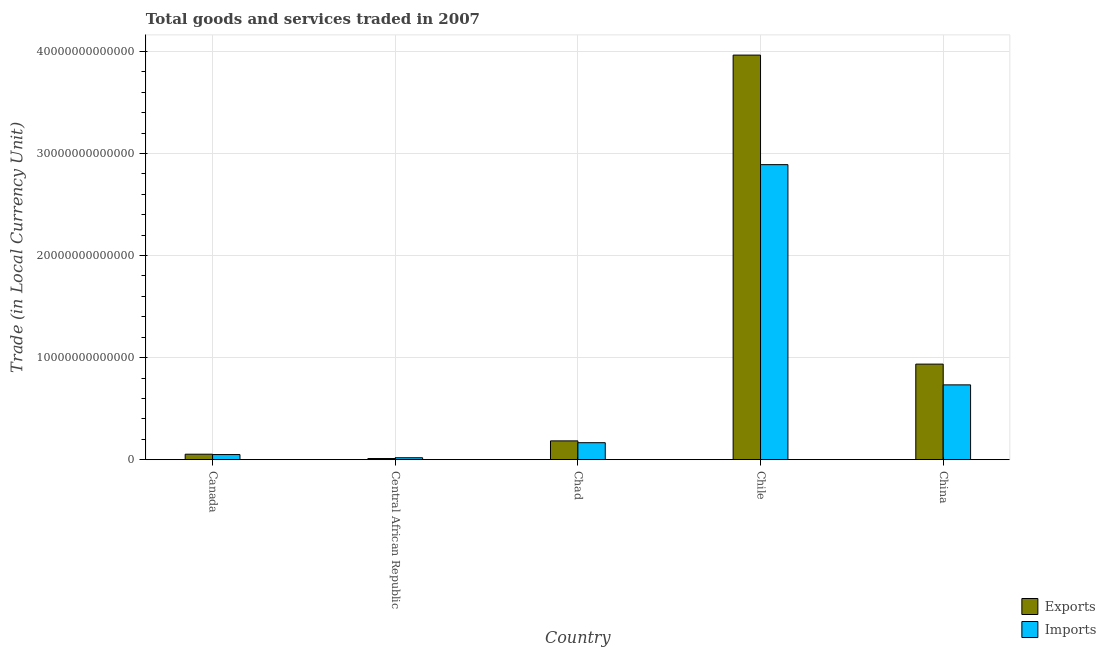How many groups of bars are there?
Your answer should be compact. 5. Are the number of bars per tick equal to the number of legend labels?
Give a very brief answer. Yes. What is the label of the 5th group of bars from the left?
Provide a succinct answer. China. What is the export of goods and services in China?
Make the answer very short. 9.36e+12. Across all countries, what is the maximum export of goods and services?
Make the answer very short. 3.96e+13. Across all countries, what is the minimum export of goods and services?
Make the answer very short. 1.15e+11. In which country was the imports of goods and services minimum?
Your answer should be compact. Central African Republic. What is the total imports of goods and services in the graph?
Your answer should be compact. 3.86e+13. What is the difference between the imports of goods and services in Chile and that in China?
Your answer should be compact. 2.16e+13. What is the difference between the export of goods and services in Chad and the imports of goods and services in Chile?
Give a very brief answer. -2.71e+13. What is the average imports of goods and services per country?
Ensure brevity in your answer.  7.72e+12. What is the difference between the imports of goods and services and export of goods and services in Canada?
Provide a succinct answer. -3.33e+1. What is the ratio of the imports of goods and services in Canada to that in Central African Republic?
Provide a succinct answer. 2.64. Is the difference between the export of goods and services in Canada and Chad greater than the difference between the imports of goods and services in Canada and Chad?
Provide a short and direct response. No. What is the difference between the highest and the second highest imports of goods and services?
Give a very brief answer. 2.16e+13. What is the difference between the highest and the lowest imports of goods and services?
Your response must be concise. 2.87e+13. In how many countries, is the export of goods and services greater than the average export of goods and services taken over all countries?
Provide a short and direct response. 1. Is the sum of the export of goods and services in Canada and Chad greater than the maximum imports of goods and services across all countries?
Provide a short and direct response. No. What does the 2nd bar from the left in Chile represents?
Make the answer very short. Imports. What does the 1st bar from the right in Chile represents?
Give a very brief answer. Imports. What is the difference between two consecutive major ticks on the Y-axis?
Provide a succinct answer. 1.00e+13. Are the values on the major ticks of Y-axis written in scientific E-notation?
Provide a short and direct response. No. Does the graph contain any zero values?
Make the answer very short. No. Does the graph contain grids?
Provide a succinct answer. Yes. How many legend labels are there?
Offer a terse response. 2. What is the title of the graph?
Ensure brevity in your answer.  Total goods and services traded in 2007. Does "Non-residents" appear as one of the legend labels in the graph?
Provide a succinct answer. No. What is the label or title of the X-axis?
Your answer should be compact. Country. What is the label or title of the Y-axis?
Offer a terse response. Trade (in Local Currency Unit). What is the Trade (in Local Currency Unit) in Exports in Canada?
Your response must be concise. 5.37e+11. What is the Trade (in Local Currency Unit) of Imports in Canada?
Your response must be concise. 5.04e+11. What is the Trade (in Local Currency Unit) of Exports in Central African Republic?
Offer a terse response. 1.15e+11. What is the Trade (in Local Currency Unit) of Imports in Central African Republic?
Ensure brevity in your answer.  1.91e+11. What is the Trade (in Local Currency Unit) in Exports in Chad?
Ensure brevity in your answer.  1.84e+12. What is the Trade (in Local Currency Unit) in Imports in Chad?
Your answer should be very brief. 1.67e+12. What is the Trade (in Local Currency Unit) of Exports in Chile?
Your response must be concise. 3.96e+13. What is the Trade (in Local Currency Unit) in Imports in Chile?
Provide a succinct answer. 2.89e+13. What is the Trade (in Local Currency Unit) of Exports in China?
Give a very brief answer. 9.36e+12. What is the Trade (in Local Currency Unit) in Imports in China?
Give a very brief answer. 7.33e+12. Across all countries, what is the maximum Trade (in Local Currency Unit) in Exports?
Give a very brief answer. 3.96e+13. Across all countries, what is the maximum Trade (in Local Currency Unit) of Imports?
Ensure brevity in your answer.  2.89e+13. Across all countries, what is the minimum Trade (in Local Currency Unit) of Exports?
Your answer should be very brief. 1.15e+11. Across all countries, what is the minimum Trade (in Local Currency Unit) of Imports?
Your answer should be very brief. 1.91e+11. What is the total Trade (in Local Currency Unit) in Exports in the graph?
Provide a short and direct response. 5.15e+13. What is the total Trade (in Local Currency Unit) of Imports in the graph?
Ensure brevity in your answer.  3.86e+13. What is the difference between the Trade (in Local Currency Unit) of Exports in Canada and that in Central African Republic?
Keep it short and to the point. 4.23e+11. What is the difference between the Trade (in Local Currency Unit) in Imports in Canada and that in Central African Republic?
Your answer should be compact. 3.13e+11. What is the difference between the Trade (in Local Currency Unit) of Exports in Canada and that in Chad?
Make the answer very short. -1.31e+12. What is the difference between the Trade (in Local Currency Unit) of Imports in Canada and that in Chad?
Offer a terse response. -1.16e+12. What is the difference between the Trade (in Local Currency Unit) of Exports in Canada and that in Chile?
Give a very brief answer. -3.91e+13. What is the difference between the Trade (in Local Currency Unit) in Imports in Canada and that in Chile?
Offer a terse response. -2.84e+13. What is the difference between the Trade (in Local Currency Unit) of Exports in Canada and that in China?
Ensure brevity in your answer.  -8.83e+12. What is the difference between the Trade (in Local Currency Unit) in Imports in Canada and that in China?
Your answer should be very brief. -6.83e+12. What is the difference between the Trade (in Local Currency Unit) in Exports in Central African Republic and that in Chad?
Give a very brief answer. -1.73e+12. What is the difference between the Trade (in Local Currency Unit) of Imports in Central African Republic and that in Chad?
Make the answer very short. -1.47e+12. What is the difference between the Trade (in Local Currency Unit) in Exports in Central African Republic and that in Chile?
Your answer should be very brief. -3.95e+13. What is the difference between the Trade (in Local Currency Unit) of Imports in Central African Republic and that in Chile?
Offer a terse response. -2.87e+13. What is the difference between the Trade (in Local Currency Unit) in Exports in Central African Republic and that in China?
Your answer should be very brief. -9.25e+12. What is the difference between the Trade (in Local Currency Unit) of Imports in Central African Republic and that in China?
Provide a short and direct response. -7.14e+12. What is the difference between the Trade (in Local Currency Unit) in Exports in Chad and that in Chile?
Ensure brevity in your answer.  -3.78e+13. What is the difference between the Trade (in Local Currency Unit) of Imports in Chad and that in Chile?
Provide a succinct answer. -2.72e+13. What is the difference between the Trade (in Local Currency Unit) of Exports in Chad and that in China?
Ensure brevity in your answer.  -7.52e+12. What is the difference between the Trade (in Local Currency Unit) of Imports in Chad and that in China?
Keep it short and to the point. -5.66e+12. What is the difference between the Trade (in Local Currency Unit) of Exports in Chile and that in China?
Give a very brief answer. 3.03e+13. What is the difference between the Trade (in Local Currency Unit) in Imports in Chile and that in China?
Ensure brevity in your answer.  2.16e+13. What is the difference between the Trade (in Local Currency Unit) in Exports in Canada and the Trade (in Local Currency Unit) in Imports in Central African Republic?
Your response must be concise. 3.47e+11. What is the difference between the Trade (in Local Currency Unit) in Exports in Canada and the Trade (in Local Currency Unit) in Imports in Chad?
Make the answer very short. -1.13e+12. What is the difference between the Trade (in Local Currency Unit) of Exports in Canada and the Trade (in Local Currency Unit) of Imports in Chile?
Provide a succinct answer. -2.84e+13. What is the difference between the Trade (in Local Currency Unit) in Exports in Canada and the Trade (in Local Currency Unit) in Imports in China?
Your response must be concise. -6.79e+12. What is the difference between the Trade (in Local Currency Unit) of Exports in Central African Republic and the Trade (in Local Currency Unit) of Imports in Chad?
Give a very brief answer. -1.55e+12. What is the difference between the Trade (in Local Currency Unit) of Exports in Central African Republic and the Trade (in Local Currency Unit) of Imports in Chile?
Give a very brief answer. -2.88e+13. What is the difference between the Trade (in Local Currency Unit) of Exports in Central African Republic and the Trade (in Local Currency Unit) of Imports in China?
Offer a very short reply. -7.21e+12. What is the difference between the Trade (in Local Currency Unit) of Exports in Chad and the Trade (in Local Currency Unit) of Imports in Chile?
Your answer should be compact. -2.71e+13. What is the difference between the Trade (in Local Currency Unit) of Exports in Chad and the Trade (in Local Currency Unit) of Imports in China?
Your response must be concise. -5.49e+12. What is the difference between the Trade (in Local Currency Unit) of Exports in Chile and the Trade (in Local Currency Unit) of Imports in China?
Make the answer very short. 3.23e+13. What is the average Trade (in Local Currency Unit) of Exports per country?
Provide a short and direct response. 1.03e+13. What is the average Trade (in Local Currency Unit) in Imports per country?
Your answer should be very brief. 7.72e+12. What is the difference between the Trade (in Local Currency Unit) of Exports and Trade (in Local Currency Unit) of Imports in Canada?
Offer a very short reply. 3.33e+1. What is the difference between the Trade (in Local Currency Unit) in Exports and Trade (in Local Currency Unit) in Imports in Central African Republic?
Keep it short and to the point. -7.61e+1. What is the difference between the Trade (in Local Currency Unit) in Exports and Trade (in Local Currency Unit) in Imports in Chad?
Provide a succinct answer. 1.77e+11. What is the difference between the Trade (in Local Currency Unit) in Exports and Trade (in Local Currency Unit) in Imports in Chile?
Offer a very short reply. 1.07e+13. What is the difference between the Trade (in Local Currency Unit) of Exports and Trade (in Local Currency Unit) of Imports in China?
Provide a succinct answer. 2.03e+12. What is the ratio of the Trade (in Local Currency Unit) in Exports in Canada to that in Central African Republic?
Give a very brief answer. 4.68. What is the ratio of the Trade (in Local Currency Unit) in Imports in Canada to that in Central African Republic?
Your answer should be compact. 2.64. What is the ratio of the Trade (in Local Currency Unit) in Exports in Canada to that in Chad?
Provide a short and direct response. 0.29. What is the ratio of the Trade (in Local Currency Unit) in Imports in Canada to that in Chad?
Provide a short and direct response. 0.3. What is the ratio of the Trade (in Local Currency Unit) of Exports in Canada to that in Chile?
Your answer should be very brief. 0.01. What is the ratio of the Trade (in Local Currency Unit) in Imports in Canada to that in Chile?
Make the answer very short. 0.02. What is the ratio of the Trade (in Local Currency Unit) of Exports in Canada to that in China?
Offer a terse response. 0.06. What is the ratio of the Trade (in Local Currency Unit) in Imports in Canada to that in China?
Ensure brevity in your answer.  0.07. What is the ratio of the Trade (in Local Currency Unit) of Exports in Central African Republic to that in Chad?
Provide a succinct answer. 0.06. What is the ratio of the Trade (in Local Currency Unit) of Imports in Central African Republic to that in Chad?
Keep it short and to the point. 0.11. What is the ratio of the Trade (in Local Currency Unit) in Exports in Central African Republic to that in Chile?
Ensure brevity in your answer.  0. What is the ratio of the Trade (in Local Currency Unit) of Imports in Central African Republic to that in Chile?
Ensure brevity in your answer.  0.01. What is the ratio of the Trade (in Local Currency Unit) of Exports in Central African Republic to that in China?
Offer a very short reply. 0.01. What is the ratio of the Trade (in Local Currency Unit) in Imports in Central African Republic to that in China?
Offer a very short reply. 0.03. What is the ratio of the Trade (in Local Currency Unit) in Exports in Chad to that in Chile?
Your answer should be very brief. 0.05. What is the ratio of the Trade (in Local Currency Unit) of Imports in Chad to that in Chile?
Your response must be concise. 0.06. What is the ratio of the Trade (in Local Currency Unit) of Exports in Chad to that in China?
Provide a succinct answer. 0.2. What is the ratio of the Trade (in Local Currency Unit) of Imports in Chad to that in China?
Your answer should be very brief. 0.23. What is the ratio of the Trade (in Local Currency Unit) of Exports in Chile to that in China?
Offer a terse response. 4.23. What is the ratio of the Trade (in Local Currency Unit) in Imports in Chile to that in China?
Make the answer very short. 3.94. What is the difference between the highest and the second highest Trade (in Local Currency Unit) of Exports?
Your response must be concise. 3.03e+13. What is the difference between the highest and the second highest Trade (in Local Currency Unit) of Imports?
Your answer should be very brief. 2.16e+13. What is the difference between the highest and the lowest Trade (in Local Currency Unit) of Exports?
Offer a very short reply. 3.95e+13. What is the difference between the highest and the lowest Trade (in Local Currency Unit) in Imports?
Offer a very short reply. 2.87e+13. 